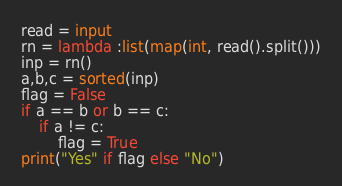<code> <loc_0><loc_0><loc_500><loc_500><_Python_>read = input 
rn = lambda :list(map(int, read().split()))
inp = rn()
a,b,c = sorted(inp)
flag = False
if a == b or b == c:
    if a != c:
        flag = True
print("Yes" if flag else "No")</code> 